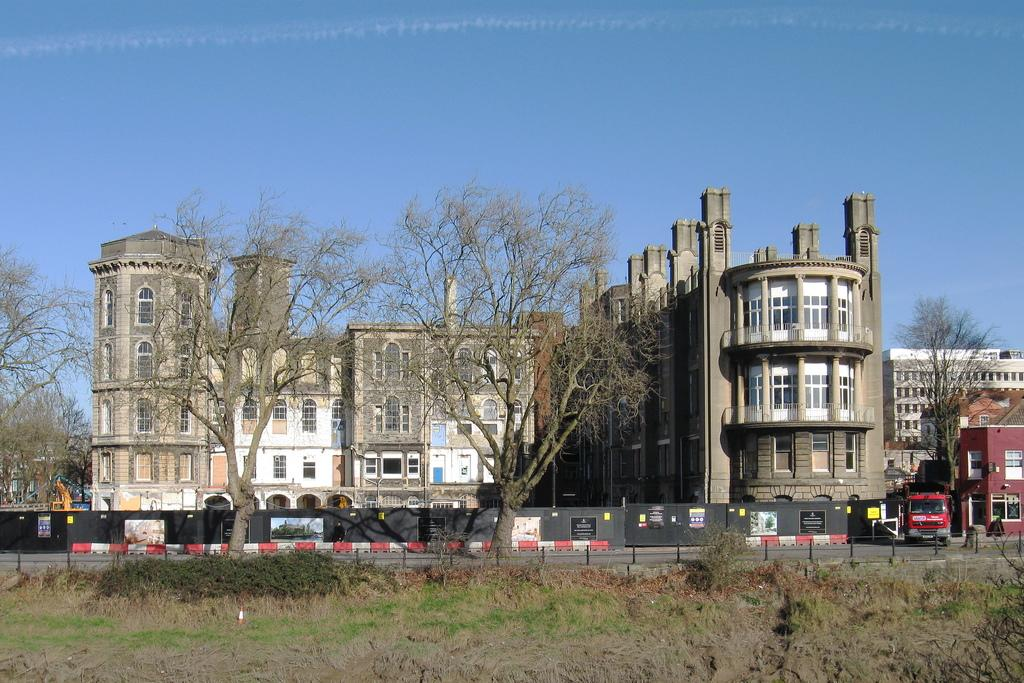What type of building is in the image? There is an old castle-type building in the image. What feature of the building is mentioned in the facts? The building has many windows. What can be seen in front of the building? There are two dry trees in front of the building. What type of barrier is present in the image? There is fencing railing in the front bottom side of the image. What is visible beneath the building? There is a ground visible in the image. What type of glue is being used to hold the lamp in the image? There is no lamp present in the image, so there is no glue being used to hold it. What letter is visible on the building in the image? There is no letter visible on the building in the image. 